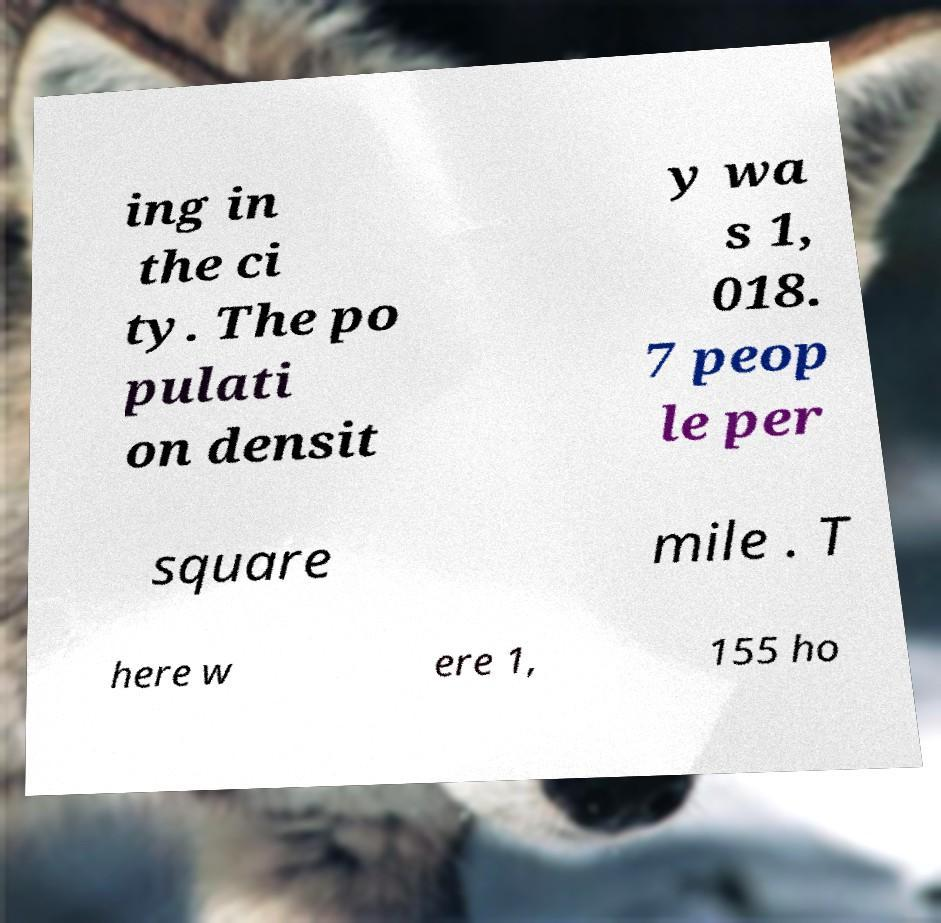I need the written content from this picture converted into text. Can you do that? ing in the ci ty. The po pulati on densit y wa s 1, 018. 7 peop le per square mile . T here w ere 1, 155 ho 